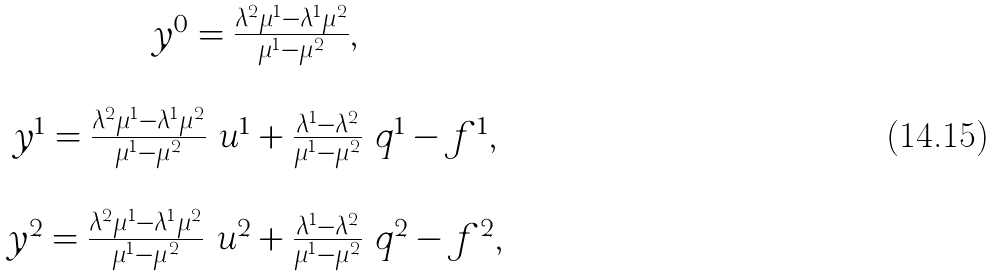Convert formula to latex. <formula><loc_0><loc_0><loc_500><loc_500>\begin{array} { c } y ^ { 0 } = \frac { \lambda ^ { 2 } \mu ^ { 1 } - \lambda ^ { 1 } \mu ^ { 2 } } { \mu ^ { 1 } - \mu ^ { 2 } } , \\ \ \\ y ^ { 1 } = \frac { \lambda ^ { 2 } \mu ^ { 1 } - \lambda ^ { 1 } \mu ^ { 2 } } { \mu ^ { 1 } - \mu ^ { 2 } } \ u ^ { 1 } + \frac { \lambda ^ { 1 } - \lambda ^ { 2 } } { \mu ^ { 1 } - \mu ^ { 2 } } \ q ^ { 1 } - f ^ { 1 } , \\ \ \\ y ^ { 2 } = \frac { \lambda ^ { 2 } \mu ^ { 1 } - \lambda ^ { 1 } \mu ^ { 2 } } { \mu ^ { 1 } - \mu ^ { 2 } } \ u ^ { 2 } + \frac { \lambda ^ { 1 } - \lambda ^ { 2 } } { \mu ^ { 1 } - \mu ^ { 2 } } \ q ^ { 2 } - f ^ { 2 } , \end{array}</formula> 